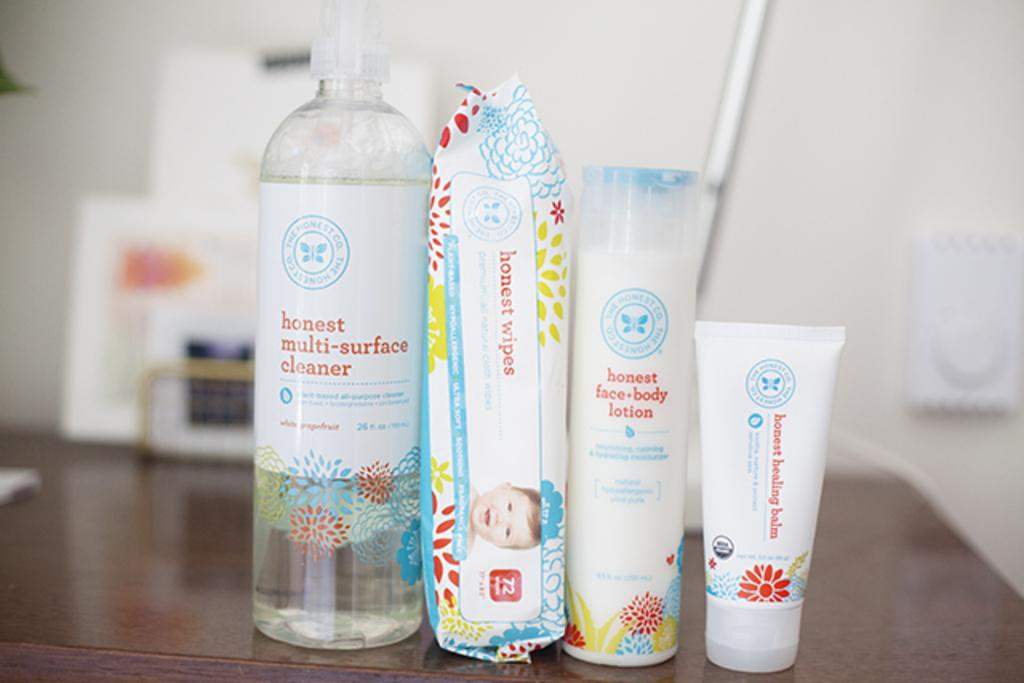What type of person can be seen in the image? There is a cleaner in the image. What tools are visible in the image? There are wipers in the image. What personal care items are present in the image? There is body lotion and baby cream in the image. Where are the items placed in the image? The items are placed on a table. What can be seen in the background of the image? There is a wall in the background of the image, and there are products visible in the background. Can you see a cup being used by the cleaner in the image? There is no cup visible in the image, and the cleaner is not using any cup. 